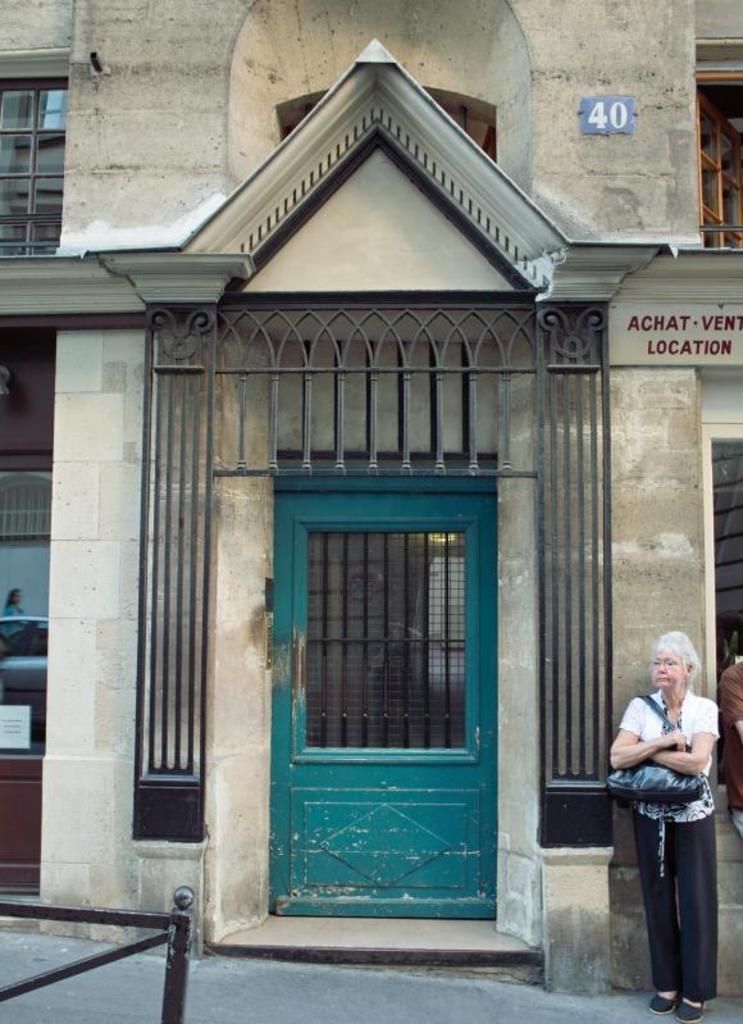Could you give a brief overview of what you see in this image? In this image we can see a house with roof, windows and a door. On the right side we can see a woman wearing a bag standing on the road. 